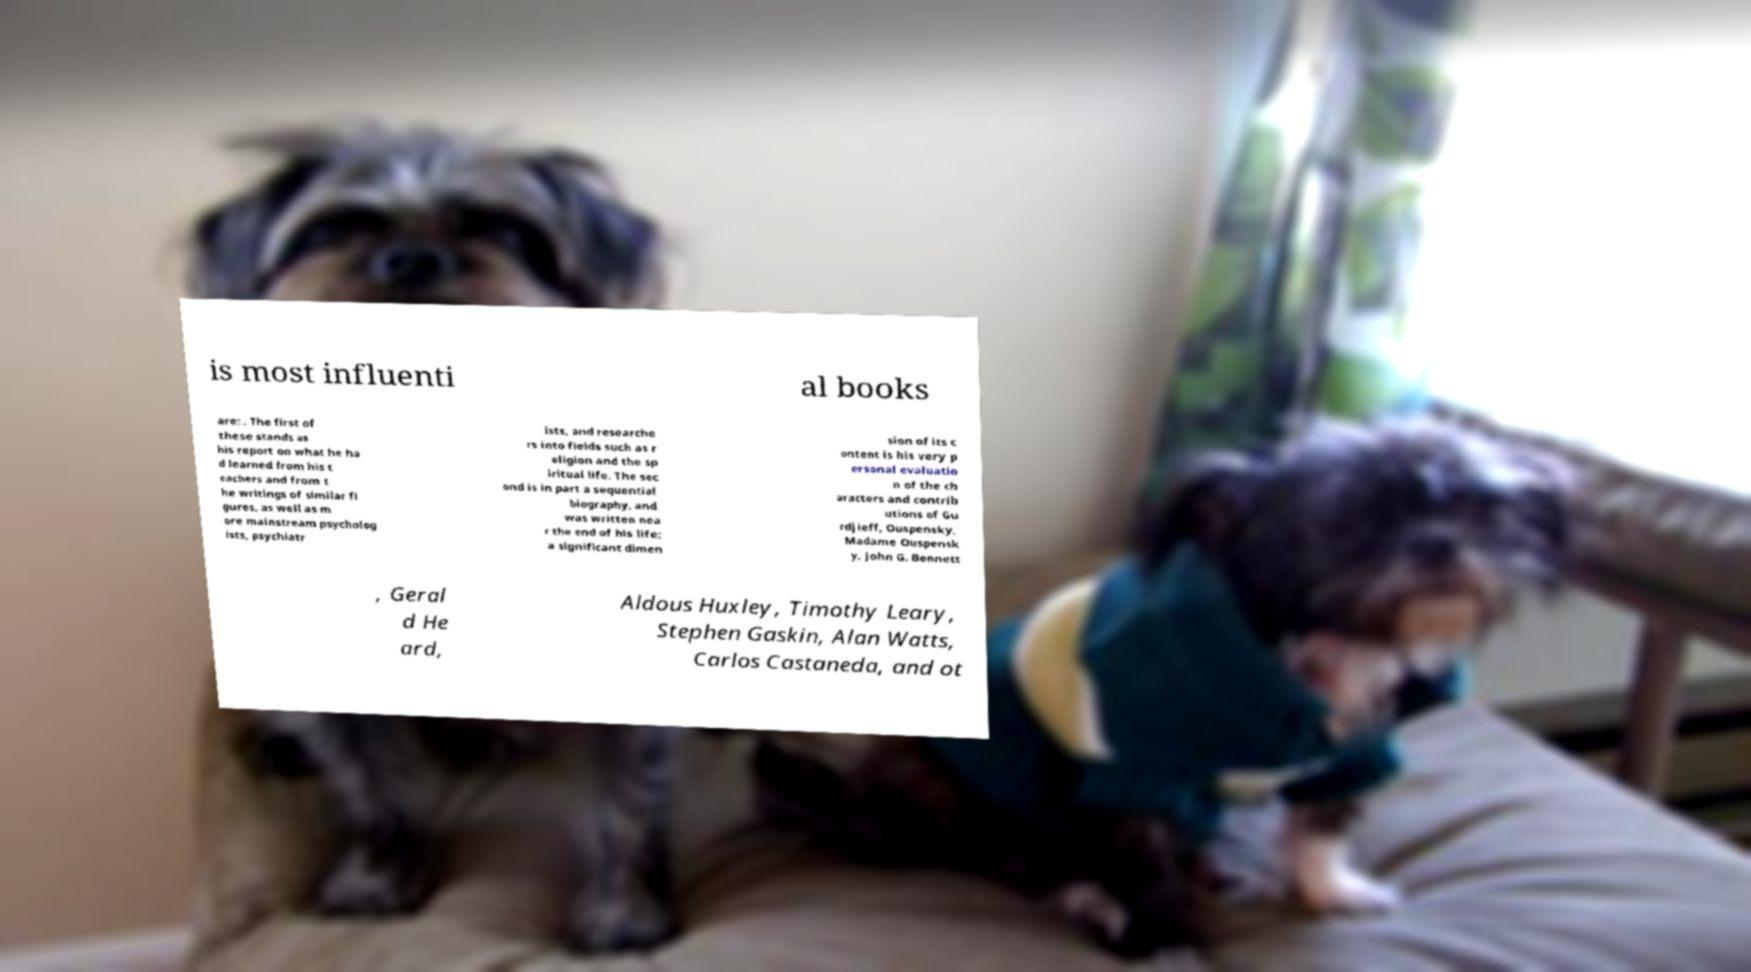Could you extract and type out the text from this image? is most influenti al books are: . The first of these stands as his report on what he ha d learned from his t eachers and from t he writings of similar fi gures, as well as m ore mainstream psycholog ists, psychiatr ists, and researche rs into fields such as r eligion and the sp iritual life. The sec ond is in part a sequential biography, and was written nea r the end of his life; a significant dimen sion of its c ontent is his very p ersonal evaluatio n of the ch aracters and contrib utions of Gu rdjieff, Ouspensky, Madame Ouspensk y, John G. Bennett , Geral d He ard, Aldous Huxley, Timothy Leary, Stephen Gaskin, Alan Watts, Carlos Castaneda, and ot 